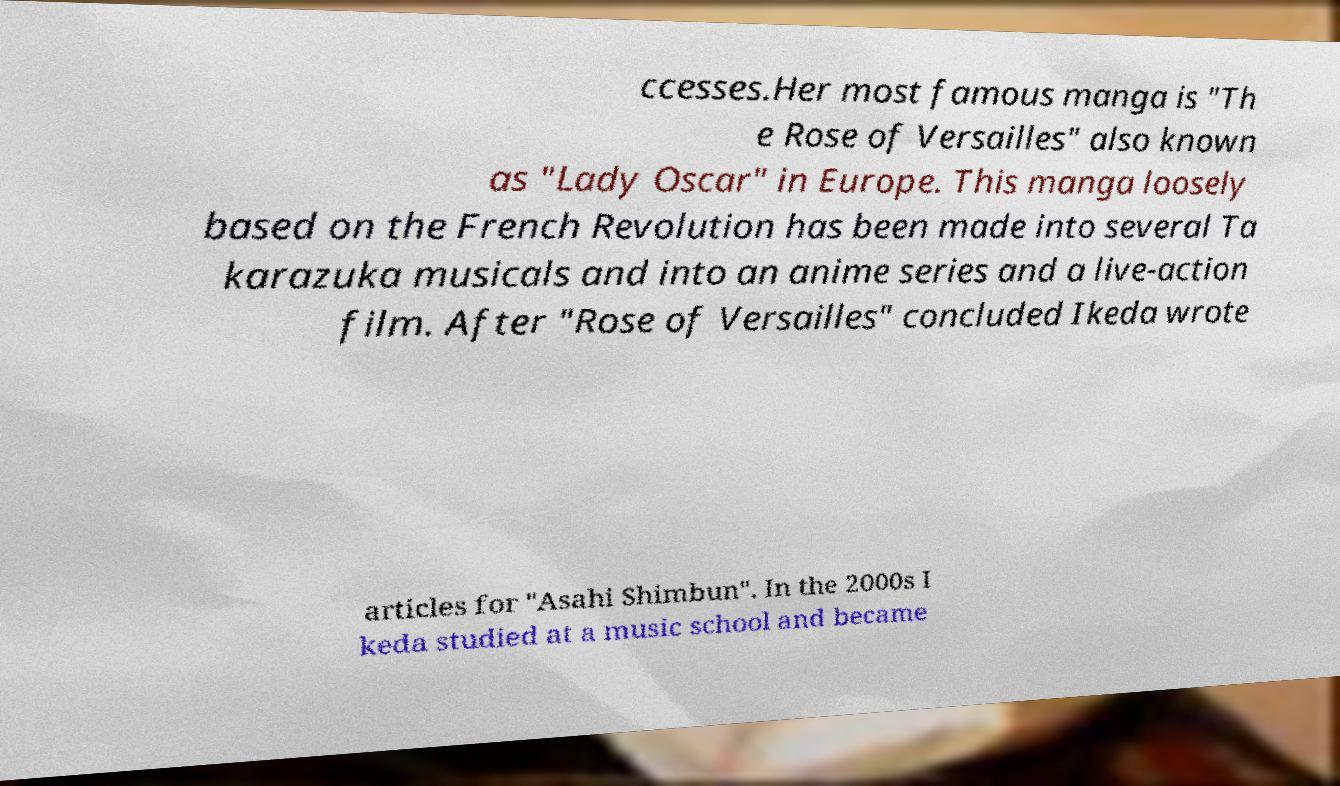What messages or text are displayed in this image? I need them in a readable, typed format. ccesses.Her most famous manga is "Th e Rose of Versailles" also known as "Lady Oscar" in Europe. This manga loosely based on the French Revolution has been made into several Ta karazuka musicals and into an anime series and a live-action film. After "Rose of Versailles" concluded Ikeda wrote articles for "Asahi Shimbun". In the 2000s I keda studied at a music school and became 